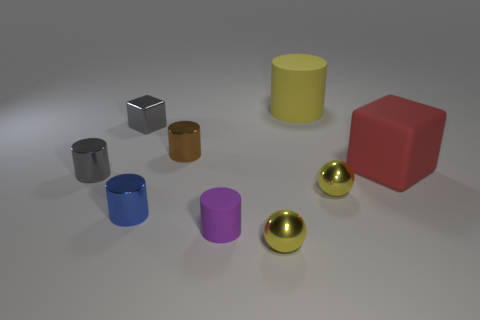How many other things are made of the same material as the red cube?
Give a very brief answer. 2. What color is the object that is both on the right side of the purple thing and behind the tiny brown metallic cylinder?
Ensure brevity in your answer.  Yellow. How many things are cylinders that are behind the small gray metal cylinder or small gray metal things?
Offer a terse response. 4. How many other objects are the same color as the big cube?
Your response must be concise. 0. Are there the same number of tiny gray objects that are on the right side of the big cylinder and small blue metallic balls?
Offer a very short reply. Yes. What number of yellow cylinders are on the right side of the metal ball in front of the small purple matte cylinder in front of the brown metal object?
Make the answer very short. 1. Is there anything else that has the same size as the gray metallic cylinder?
Provide a short and direct response. Yes. Do the blue cylinder and the yellow metallic ball behind the blue cylinder have the same size?
Offer a very short reply. Yes. How many gray things are there?
Ensure brevity in your answer.  2. There is a yellow thing behind the large red rubber thing; is its size the same as the red thing that is in front of the tiny brown thing?
Ensure brevity in your answer.  Yes. 